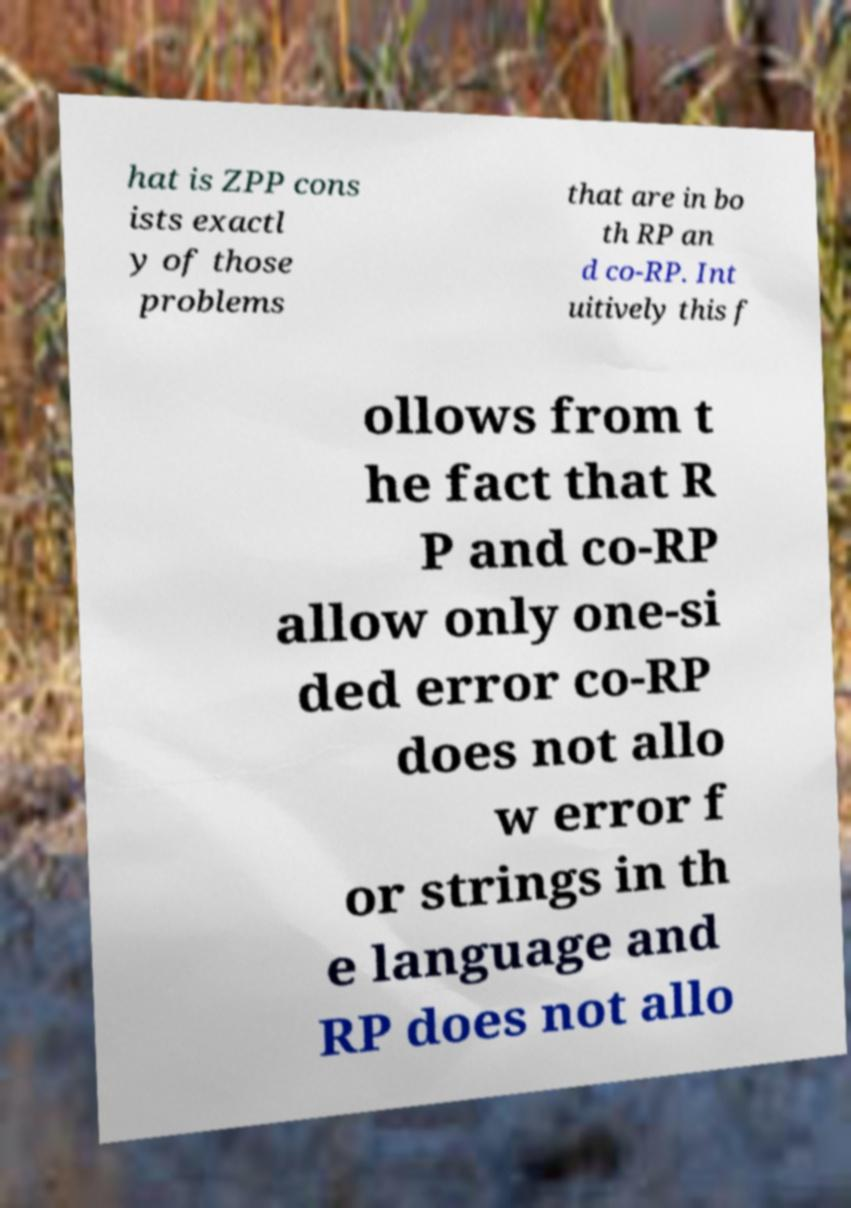Can you accurately transcribe the text from the provided image for me? hat is ZPP cons ists exactl y of those problems that are in bo th RP an d co-RP. Int uitively this f ollows from t he fact that R P and co-RP allow only one-si ded error co-RP does not allo w error f or strings in th e language and RP does not allo 